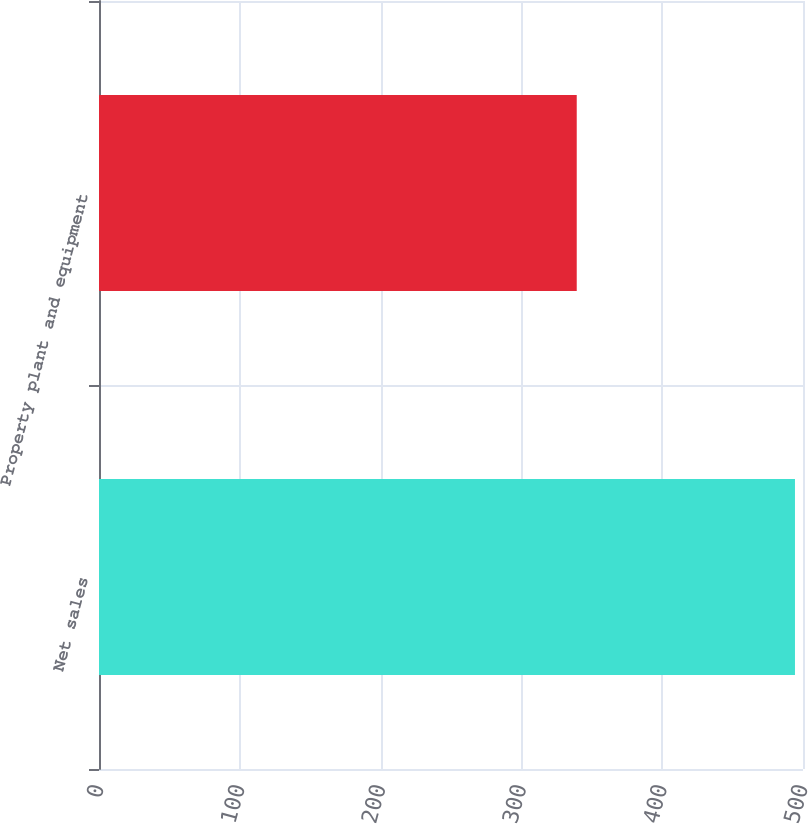<chart> <loc_0><loc_0><loc_500><loc_500><bar_chart><fcel>Net sales<fcel>Property plant and equipment<nl><fcel>494.3<fcel>339.3<nl></chart> 